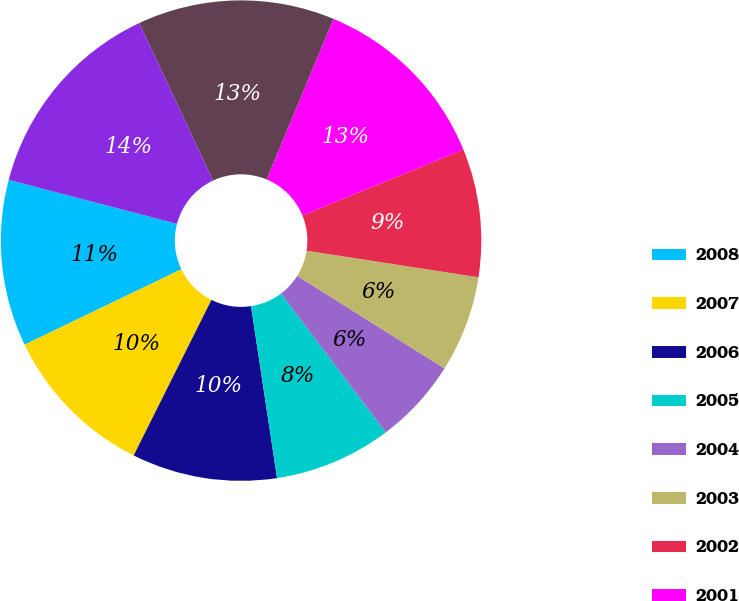Convert chart to OTSL. <chart><loc_0><loc_0><loc_500><loc_500><pie_chart><fcel>2008<fcel>2007<fcel>2006<fcel>2005<fcel>2004<fcel>2003<fcel>2002<fcel>2001<fcel>2000<fcel>1999<nl><fcel>11.2%<fcel>10.49%<fcel>9.77%<fcel>7.9%<fcel>5.78%<fcel>6.49%<fcel>8.62%<fcel>12.54%<fcel>13.25%<fcel>13.96%<nl></chart> 